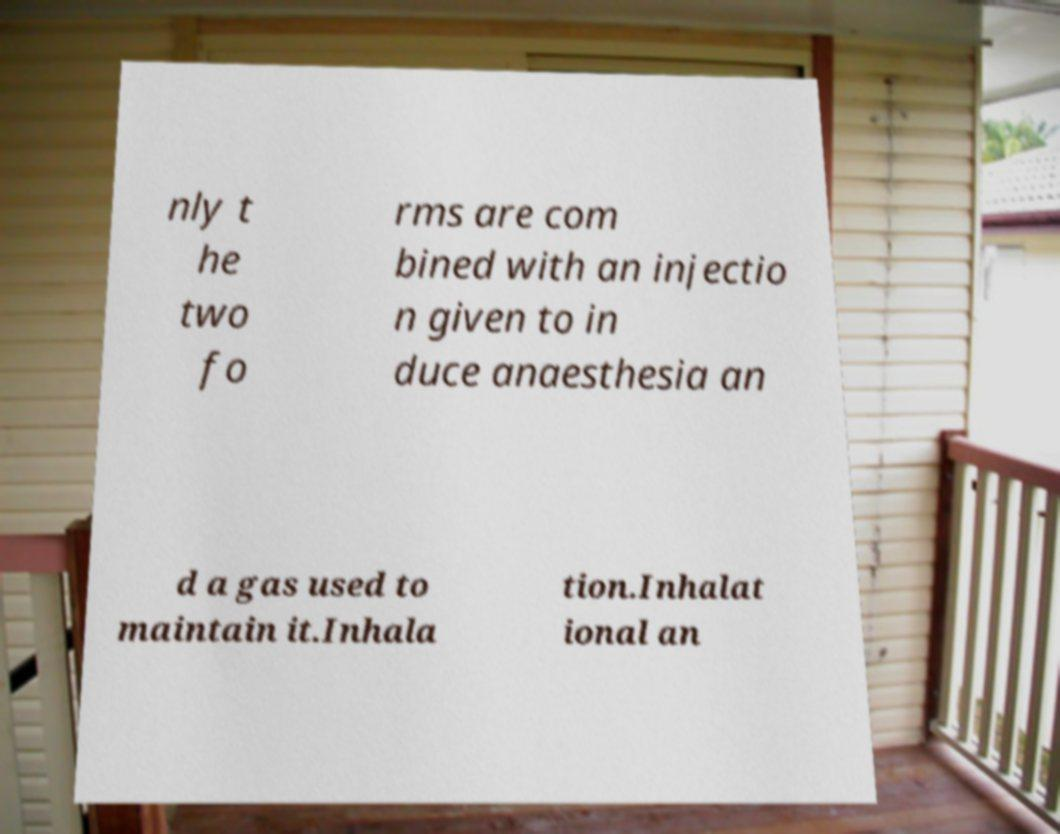Can you accurately transcribe the text from the provided image for me? nly t he two fo rms are com bined with an injectio n given to in duce anaesthesia an d a gas used to maintain it.Inhala tion.Inhalat ional an 